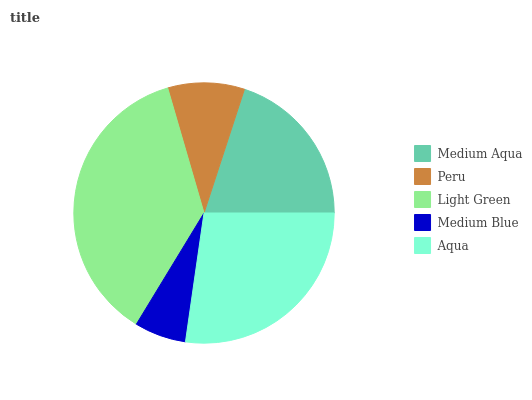Is Medium Blue the minimum?
Answer yes or no. Yes. Is Light Green the maximum?
Answer yes or no. Yes. Is Peru the minimum?
Answer yes or no. No. Is Peru the maximum?
Answer yes or no. No. Is Medium Aqua greater than Peru?
Answer yes or no. Yes. Is Peru less than Medium Aqua?
Answer yes or no. Yes. Is Peru greater than Medium Aqua?
Answer yes or no. No. Is Medium Aqua less than Peru?
Answer yes or no. No. Is Medium Aqua the high median?
Answer yes or no. Yes. Is Medium Aqua the low median?
Answer yes or no. Yes. Is Light Green the high median?
Answer yes or no. No. Is Light Green the low median?
Answer yes or no. No. 